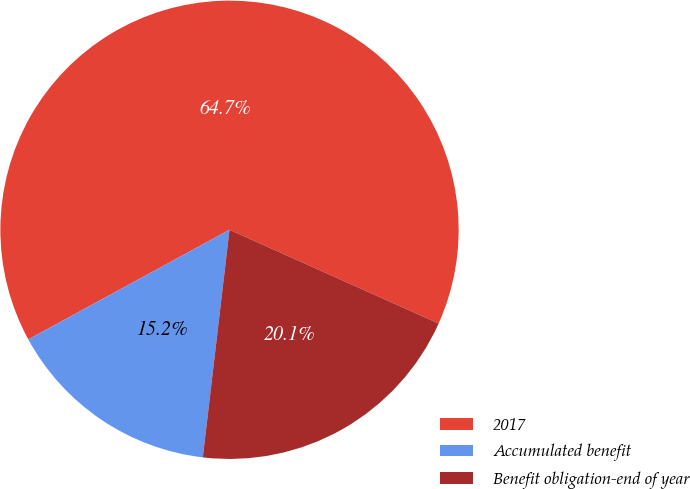<chart> <loc_0><loc_0><loc_500><loc_500><pie_chart><fcel>2017<fcel>Accumulated benefit<fcel>Benefit obligation-end of year<nl><fcel>64.65%<fcel>15.2%<fcel>20.15%<nl></chart> 